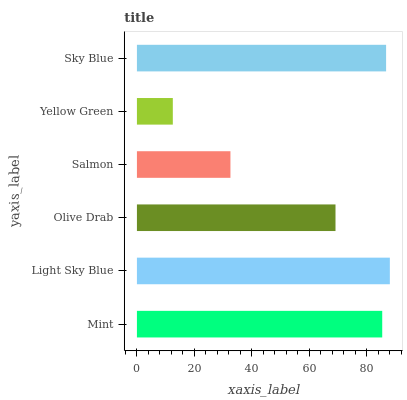Is Yellow Green the minimum?
Answer yes or no. Yes. Is Light Sky Blue the maximum?
Answer yes or no. Yes. Is Olive Drab the minimum?
Answer yes or no. No. Is Olive Drab the maximum?
Answer yes or no. No. Is Light Sky Blue greater than Olive Drab?
Answer yes or no. Yes. Is Olive Drab less than Light Sky Blue?
Answer yes or no. Yes. Is Olive Drab greater than Light Sky Blue?
Answer yes or no. No. Is Light Sky Blue less than Olive Drab?
Answer yes or no. No. Is Mint the high median?
Answer yes or no. Yes. Is Olive Drab the low median?
Answer yes or no. Yes. Is Sky Blue the high median?
Answer yes or no. No. Is Light Sky Blue the low median?
Answer yes or no. No. 